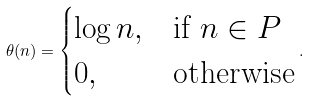Convert formula to latex. <formula><loc_0><loc_0><loc_500><loc_500>\theta ( n ) = \begin{cases} \log n , & \text {if $n \in P$} \\ 0 , & \text {otherwise} \\ \end{cases} .</formula> 